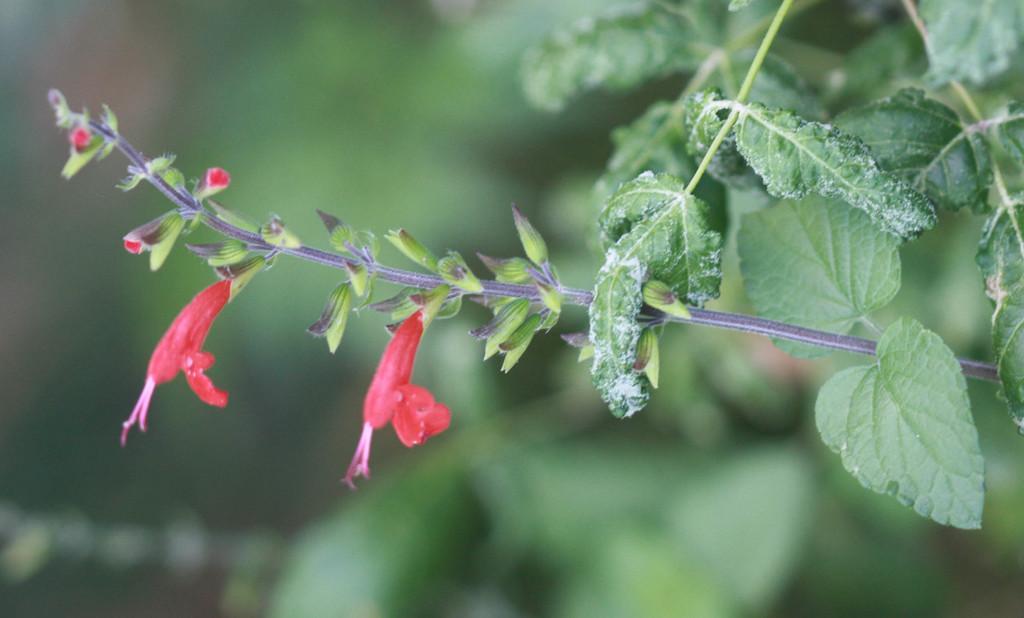How would you summarize this image in a sentence or two? In this image we can see a plant with flowers and buds and in the background the image is blurred. 